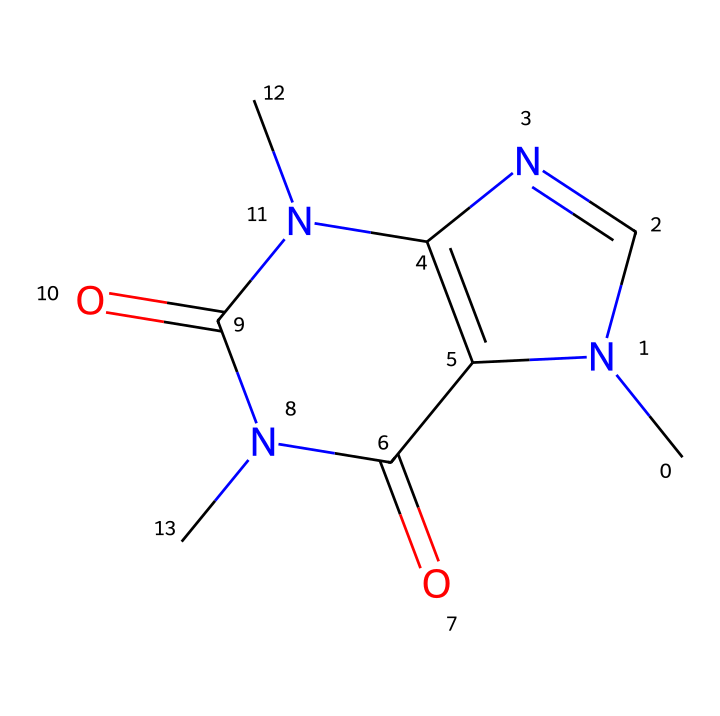What is the molecular formula of caffeine? To find the molecular formula, we analyze the SMILES representation. By counting the atoms, we find 8 carbon (C), 10 hydrogen (H), 4 nitrogen (N), and 4 oxygen (O) atoms. This gives us the formula C8H10N4O2.
Answer: C8H10N4O2 How many nitrogen atoms does caffeine contain? From the SMILES representation, we look for the nitrogen atoms. Counting reveals there are 4 nitrogen (N) atoms in the structure.
Answer: 4 What type of bonding is predominantly present in caffeine? Analyzing the chemical structure shows that caffeine consists mainly of covalent bonds as it contains sharing of electrons between carbon, nitrogen, and oxygen atoms typical in organic compounds.
Answer: covalent Which component of caffeine contributes to its stimulant effects? The nitrogen atoms within the ring structures form part of the active sites that interact with receptors in the brain, contributing to its stimulant properties.
Answer: nitrogen Is caffeine soluble in water? Caffeine, a non-electrolyte, has polar characteristics due to its functional groups (like nitrogen and oxygen), making it generally soluble in water, but not an electrolyte.
Answer: soluble What kind of functional groups are present in caffeine? By examining the structure closely, we can identify amine (due to nitrogen) and carbonyl (due to the double-bonded oxygen) functional groups as present in caffeine.
Answer: amine and carbonyl 